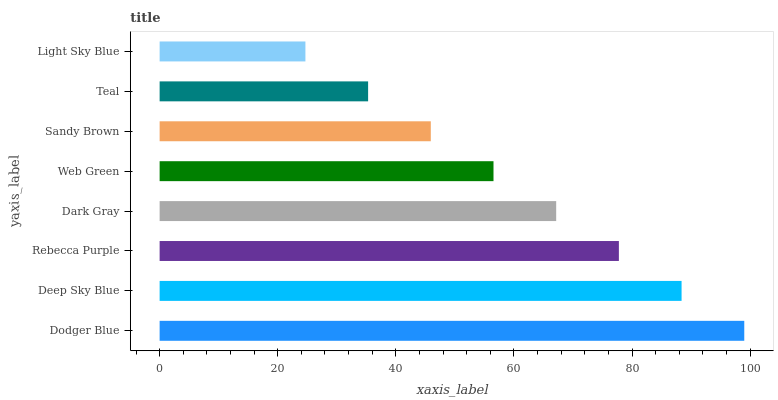Is Light Sky Blue the minimum?
Answer yes or no. Yes. Is Dodger Blue the maximum?
Answer yes or no. Yes. Is Deep Sky Blue the minimum?
Answer yes or no. No. Is Deep Sky Blue the maximum?
Answer yes or no. No. Is Dodger Blue greater than Deep Sky Blue?
Answer yes or no. Yes. Is Deep Sky Blue less than Dodger Blue?
Answer yes or no. Yes. Is Deep Sky Blue greater than Dodger Blue?
Answer yes or no. No. Is Dodger Blue less than Deep Sky Blue?
Answer yes or no. No. Is Dark Gray the high median?
Answer yes or no. Yes. Is Web Green the low median?
Answer yes or no. Yes. Is Rebecca Purple the high median?
Answer yes or no. No. Is Dark Gray the low median?
Answer yes or no. No. 